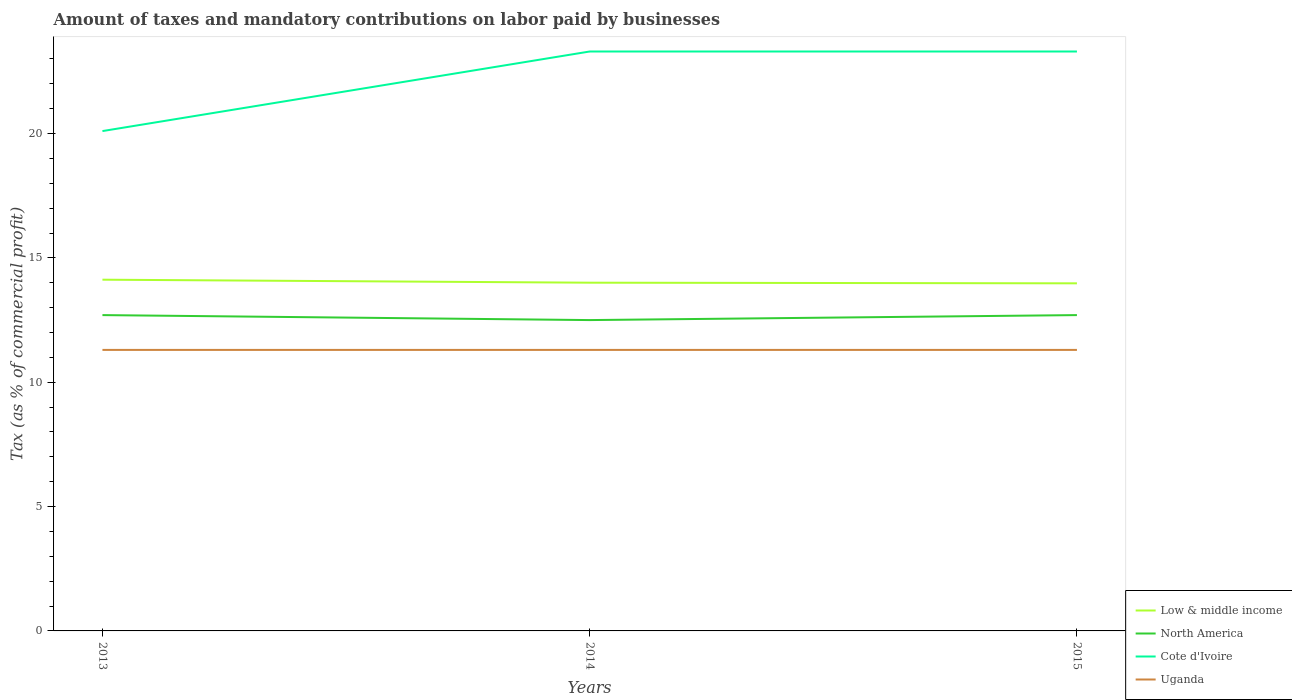Is the number of lines equal to the number of legend labels?
Your response must be concise. Yes. Across all years, what is the maximum percentage of taxes paid by businesses in Low & middle income?
Offer a very short reply. 13.98. In which year was the percentage of taxes paid by businesses in North America maximum?
Offer a terse response. 2014. What is the total percentage of taxes paid by businesses in Cote d'Ivoire in the graph?
Offer a terse response. -3.2. What is the difference between the highest and the second highest percentage of taxes paid by businesses in Cote d'Ivoire?
Offer a very short reply. 3.2. What is the difference between the highest and the lowest percentage of taxes paid by businesses in Cote d'Ivoire?
Your response must be concise. 2. Is the percentage of taxes paid by businesses in Uganda strictly greater than the percentage of taxes paid by businesses in North America over the years?
Your answer should be compact. Yes. What is the difference between two consecutive major ticks on the Y-axis?
Your response must be concise. 5. Are the values on the major ticks of Y-axis written in scientific E-notation?
Your answer should be compact. No. Does the graph contain grids?
Your answer should be compact. No. How many legend labels are there?
Provide a short and direct response. 4. What is the title of the graph?
Your answer should be very brief. Amount of taxes and mandatory contributions on labor paid by businesses. What is the label or title of the X-axis?
Give a very brief answer. Years. What is the label or title of the Y-axis?
Provide a succinct answer. Tax (as % of commercial profit). What is the Tax (as % of commercial profit) in Low & middle income in 2013?
Your answer should be compact. 14.12. What is the Tax (as % of commercial profit) in North America in 2013?
Your answer should be compact. 12.7. What is the Tax (as % of commercial profit) in Cote d'Ivoire in 2013?
Give a very brief answer. 20.1. What is the Tax (as % of commercial profit) in Uganda in 2013?
Your answer should be very brief. 11.3. What is the Tax (as % of commercial profit) of Low & middle income in 2014?
Your response must be concise. 14. What is the Tax (as % of commercial profit) in North America in 2014?
Your answer should be compact. 12.5. What is the Tax (as % of commercial profit) of Cote d'Ivoire in 2014?
Give a very brief answer. 23.3. What is the Tax (as % of commercial profit) in Uganda in 2014?
Ensure brevity in your answer.  11.3. What is the Tax (as % of commercial profit) of Low & middle income in 2015?
Ensure brevity in your answer.  13.98. What is the Tax (as % of commercial profit) in North America in 2015?
Your answer should be compact. 12.7. What is the Tax (as % of commercial profit) in Cote d'Ivoire in 2015?
Provide a short and direct response. 23.3. Across all years, what is the maximum Tax (as % of commercial profit) in Low & middle income?
Your response must be concise. 14.12. Across all years, what is the maximum Tax (as % of commercial profit) in North America?
Your answer should be very brief. 12.7. Across all years, what is the maximum Tax (as % of commercial profit) of Cote d'Ivoire?
Your response must be concise. 23.3. Across all years, what is the minimum Tax (as % of commercial profit) of Low & middle income?
Your response must be concise. 13.98. Across all years, what is the minimum Tax (as % of commercial profit) of Cote d'Ivoire?
Provide a succinct answer. 20.1. Across all years, what is the minimum Tax (as % of commercial profit) of Uganda?
Your response must be concise. 11.3. What is the total Tax (as % of commercial profit) of Low & middle income in the graph?
Your answer should be very brief. 42.1. What is the total Tax (as % of commercial profit) in North America in the graph?
Make the answer very short. 37.9. What is the total Tax (as % of commercial profit) in Cote d'Ivoire in the graph?
Give a very brief answer. 66.7. What is the total Tax (as % of commercial profit) in Uganda in the graph?
Make the answer very short. 33.9. What is the difference between the Tax (as % of commercial profit) of Low & middle income in 2013 and that in 2014?
Ensure brevity in your answer.  0.12. What is the difference between the Tax (as % of commercial profit) in North America in 2013 and that in 2014?
Give a very brief answer. 0.2. What is the difference between the Tax (as % of commercial profit) in Cote d'Ivoire in 2013 and that in 2014?
Your answer should be compact. -3.2. What is the difference between the Tax (as % of commercial profit) in Uganda in 2013 and that in 2014?
Your answer should be compact. 0. What is the difference between the Tax (as % of commercial profit) in Low & middle income in 2013 and that in 2015?
Provide a short and direct response. 0.15. What is the difference between the Tax (as % of commercial profit) in North America in 2013 and that in 2015?
Offer a very short reply. 0. What is the difference between the Tax (as % of commercial profit) in Cote d'Ivoire in 2013 and that in 2015?
Keep it short and to the point. -3.2. What is the difference between the Tax (as % of commercial profit) of Uganda in 2013 and that in 2015?
Provide a short and direct response. 0. What is the difference between the Tax (as % of commercial profit) in Low & middle income in 2014 and that in 2015?
Your response must be concise. 0.03. What is the difference between the Tax (as % of commercial profit) in North America in 2014 and that in 2015?
Your answer should be compact. -0.2. What is the difference between the Tax (as % of commercial profit) in Uganda in 2014 and that in 2015?
Your answer should be very brief. 0. What is the difference between the Tax (as % of commercial profit) of Low & middle income in 2013 and the Tax (as % of commercial profit) of North America in 2014?
Offer a terse response. 1.62. What is the difference between the Tax (as % of commercial profit) in Low & middle income in 2013 and the Tax (as % of commercial profit) in Cote d'Ivoire in 2014?
Provide a succinct answer. -9.18. What is the difference between the Tax (as % of commercial profit) of Low & middle income in 2013 and the Tax (as % of commercial profit) of Uganda in 2014?
Your answer should be very brief. 2.82. What is the difference between the Tax (as % of commercial profit) of Cote d'Ivoire in 2013 and the Tax (as % of commercial profit) of Uganda in 2014?
Provide a short and direct response. 8.8. What is the difference between the Tax (as % of commercial profit) in Low & middle income in 2013 and the Tax (as % of commercial profit) in North America in 2015?
Your answer should be compact. 1.42. What is the difference between the Tax (as % of commercial profit) of Low & middle income in 2013 and the Tax (as % of commercial profit) of Cote d'Ivoire in 2015?
Your response must be concise. -9.18. What is the difference between the Tax (as % of commercial profit) of Low & middle income in 2013 and the Tax (as % of commercial profit) of Uganda in 2015?
Offer a terse response. 2.82. What is the difference between the Tax (as % of commercial profit) in Low & middle income in 2014 and the Tax (as % of commercial profit) in North America in 2015?
Provide a succinct answer. 1.3. What is the difference between the Tax (as % of commercial profit) of Low & middle income in 2014 and the Tax (as % of commercial profit) of Cote d'Ivoire in 2015?
Your response must be concise. -9.3. What is the difference between the Tax (as % of commercial profit) of Low & middle income in 2014 and the Tax (as % of commercial profit) of Uganda in 2015?
Your answer should be compact. 2.7. What is the difference between the Tax (as % of commercial profit) of North America in 2014 and the Tax (as % of commercial profit) of Uganda in 2015?
Your response must be concise. 1.2. What is the difference between the Tax (as % of commercial profit) of Cote d'Ivoire in 2014 and the Tax (as % of commercial profit) of Uganda in 2015?
Provide a short and direct response. 12. What is the average Tax (as % of commercial profit) of Low & middle income per year?
Your response must be concise. 14.03. What is the average Tax (as % of commercial profit) in North America per year?
Give a very brief answer. 12.63. What is the average Tax (as % of commercial profit) of Cote d'Ivoire per year?
Ensure brevity in your answer.  22.23. In the year 2013, what is the difference between the Tax (as % of commercial profit) in Low & middle income and Tax (as % of commercial profit) in North America?
Provide a short and direct response. 1.42. In the year 2013, what is the difference between the Tax (as % of commercial profit) of Low & middle income and Tax (as % of commercial profit) of Cote d'Ivoire?
Ensure brevity in your answer.  -5.98. In the year 2013, what is the difference between the Tax (as % of commercial profit) of Low & middle income and Tax (as % of commercial profit) of Uganda?
Make the answer very short. 2.82. In the year 2013, what is the difference between the Tax (as % of commercial profit) in North America and Tax (as % of commercial profit) in Cote d'Ivoire?
Offer a very short reply. -7.4. In the year 2014, what is the difference between the Tax (as % of commercial profit) of Low & middle income and Tax (as % of commercial profit) of North America?
Give a very brief answer. 1.5. In the year 2014, what is the difference between the Tax (as % of commercial profit) of Low & middle income and Tax (as % of commercial profit) of Cote d'Ivoire?
Make the answer very short. -9.3. In the year 2014, what is the difference between the Tax (as % of commercial profit) of Low & middle income and Tax (as % of commercial profit) of Uganda?
Your answer should be very brief. 2.7. In the year 2014, what is the difference between the Tax (as % of commercial profit) of Cote d'Ivoire and Tax (as % of commercial profit) of Uganda?
Offer a very short reply. 12. In the year 2015, what is the difference between the Tax (as % of commercial profit) of Low & middle income and Tax (as % of commercial profit) of North America?
Keep it short and to the point. 1.28. In the year 2015, what is the difference between the Tax (as % of commercial profit) in Low & middle income and Tax (as % of commercial profit) in Cote d'Ivoire?
Offer a very short reply. -9.32. In the year 2015, what is the difference between the Tax (as % of commercial profit) of Low & middle income and Tax (as % of commercial profit) of Uganda?
Give a very brief answer. 2.68. In the year 2015, what is the difference between the Tax (as % of commercial profit) of North America and Tax (as % of commercial profit) of Cote d'Ivoire?
Offer a terse response. -10.6. In the year 2015, what is the difference between the Tax (as % of commercial profit) in North America and Tax (as % of commercial profit) in Uganda?
Ensure brevity in your answer.  1.4. What is the ratio of the Tax (as % of commercial profit) of Low & middle income in 2013 to that in 2014?
Offer a terse response. 1.01. What is the ratio of the Tax (as % of commercial profit) in North America in 2013 to that in 2014?
Your answer should be compact. 1.02. What is the ratio of the Tax (as % of commercial profit) of Cote d'Ivoire in 2013 to that in 2014?
Your answer should be compact. 0.86. What is the ratio of the Tax (as % of commercial profit) in Uganda in 2013 to that in 2014?
Your response must be concise. 1. What is the ratio of the Tax (as % of commercial profit) in Low & middle income in 2013 to that in 2015?
Provide a succinct answer. 1.01. What is the ratio of the Tax (as % of commercial profit) in North America in 2013 to that in 2015?
Keep it short and to the point. 1. What is the ratio of the Tax (as % of commercial profit) of Cote d'Ivoire in 2013 to that in 2015?
Provide a short and direct response. 0.86. What is the ratio of the Tax (as % of commercial profit) of North America in 2014 to that in 2015?
Provide a short and direct response. 0.98. What is the ratio of the Tax (as % of commercial profit) in Uganda in 2014 to that in 2015?
Offer a very short reply. 1. What is the difference between the highest and the second highest Tax (as % of commercial profit) of Low & middle income?
Offer a terse response. 0.12. What is the difference between the highest and the second highest Tax (as % of commercial profit) in North America?
Your response must be concise. 0. What is the difference between the highest and the second highest Tax (as % of commercial profit) in Uganda?
Your answer should be compact. 0. What is the difference between the highest and the lowest Tax (as % of commercial profit) in Low & middle income?
Offer a terse response. 0.15. What is the difference between the highest and the lowest Tax (as % of commercial profit) in North America?
Offer a terse response. 0.2. What is the difference between the highest and the lowest Tax (as % of commercial profit) in Cote d'Ivoire?
Make the answer very short. 3.2. 